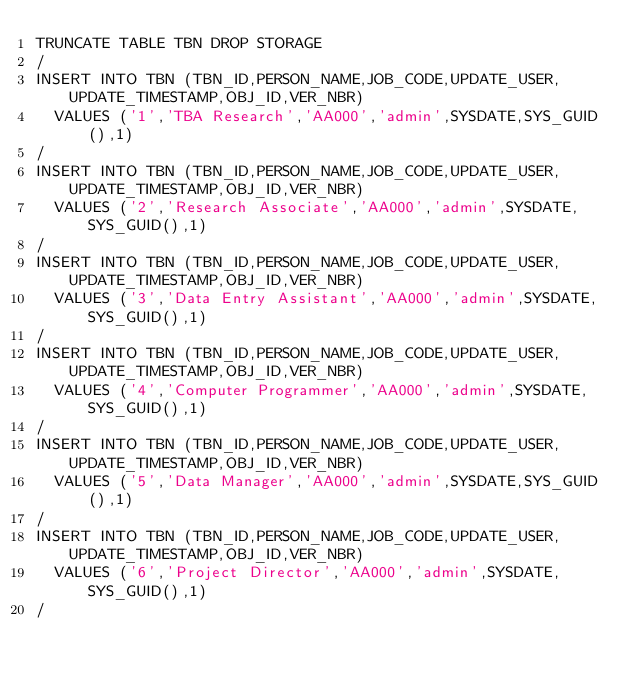Convert code to text. <code><loc_0><loc_0><loc_500><loc_500><_SQL_>TRUNCATE TABLE TBN DROP STORAGE
/
INSERT INTO TBN (TBN_ID,PERSON_NAME,JOB_CODE,UPDATE_USER,UPDATE_TIMESTAMP,OBJ_ID,VER_NBR)
  VALUES ('1','TBA Research','AA000','admin',SYSDATE,SYS_GUID(),1)
/
INSERT INTO TBN (TBN_ID,PERSON_NAME,JOB_CODE,UPDATE_USER,UPDATE_TIMESTAMP,OBJ_ID,VER_NBR)
  VALUES ('2','Research Associate','AA000','admin',SYSDATE,SYS_GUID(),1)
/
INSERT INTO TBN (TBN_ID,PERSON_NAME,JOB_CODE,UPDATE_USER,UPDATE_TIMESTAMP,OBJ_ID,VER_NBR)
  VALUES ('3','Data Entry Assistant','AA000','admin',SYSDATE,SYS_GUID(),1)
/
INSERT INTO TBN (TBN_ID,PERSON_NAME,JOB_CODE,UPDATE_USER,UPDATE_TIMESTAMP,OBJ_ID,VER_NBR)
  VALUES ('4','Computer Programmer','AA000','admin',SYSDATE,SYS_GUID(),1)
/
INSERT INTO TBN (TBN_ID,PERSON_NAME,JOB_CODE,UPDATE_USER,UPDATE_TIMESTAMP,OBJ_ID,VER_NBR)
  VALUES ('5','Data Manager','AA000','admin',SYSDATE,SYS_GUID(),1)
/
INSERT INTO TBN (TBN_ID,PERSON_NAME,JOB_CODE,UPDATE_USER,UPDATE_TIMESTAMP,OBJ_ID,VER_NBR)
  VALUES ('6','Project Director','AA000','admin',SYSDATE,SYS_GUID(),1)
/
</code> 